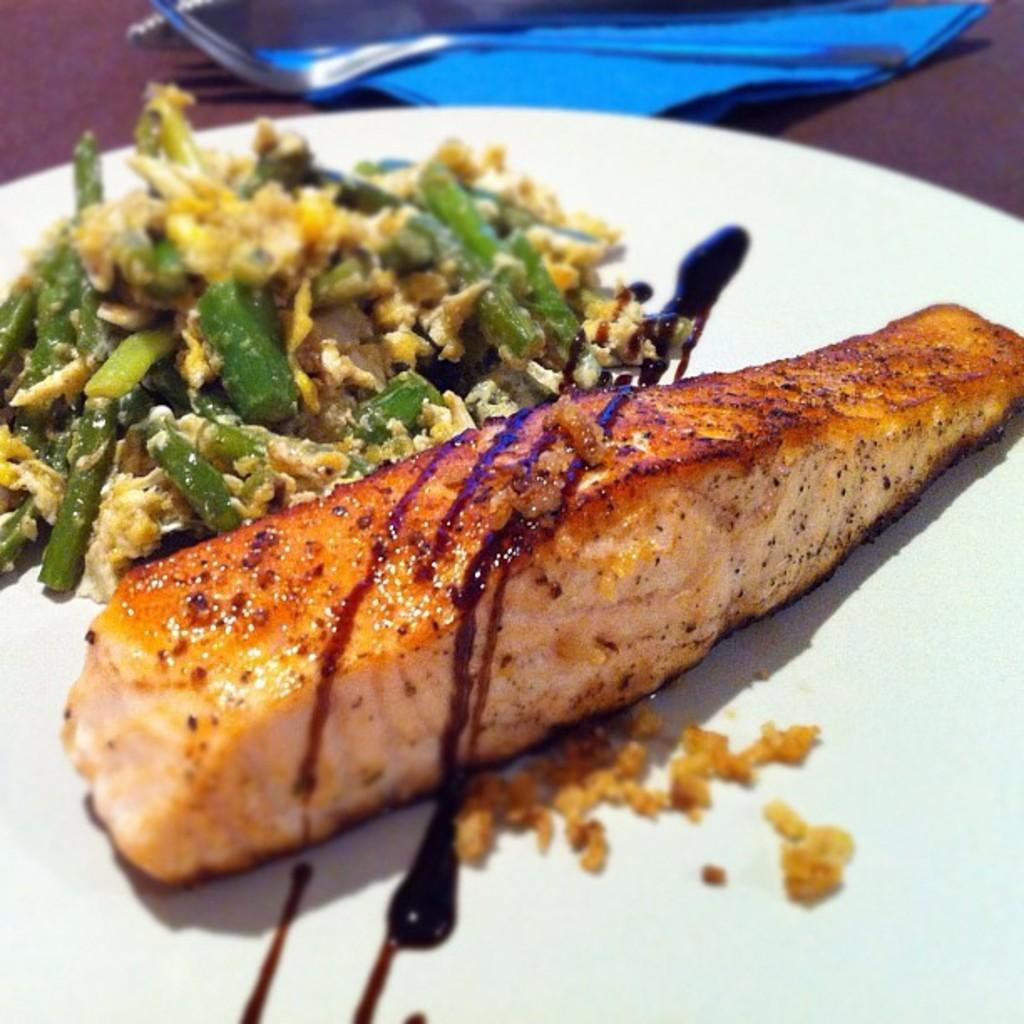What is on the plate that is visible in the image? There is food in a plate in the image. What type of furniture is present in the image? There is a table in the image. What type of quilt is draped over the table in the image? There is no quilt present in the image; only a table and a plate of food are visible. What type of meal is being served on the plate in the image? The type of meal cannot be determined from the image, as only the presence of food is mentioned. 